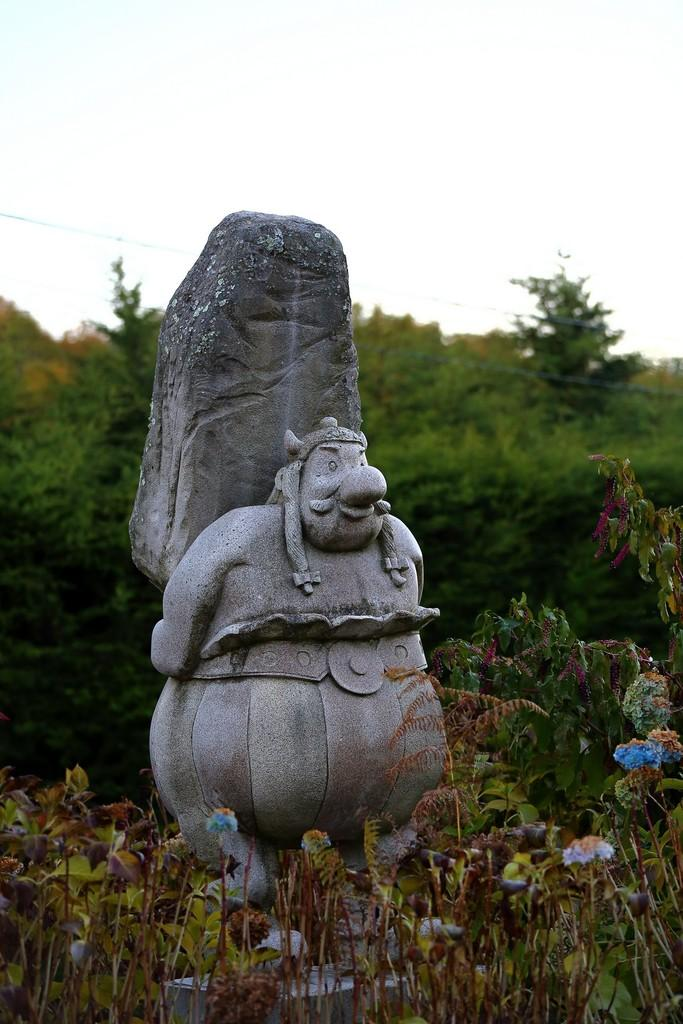What is the main subject in the image? There is a statue in the image. What is located near the statue? There are plants near the statue. What can be seen in the background of the image? There are trees and the sky visible in the background of the image. What is the opinion of the hat in the image? There is no hat present in the image, so it is not possible to determine its opinion. 